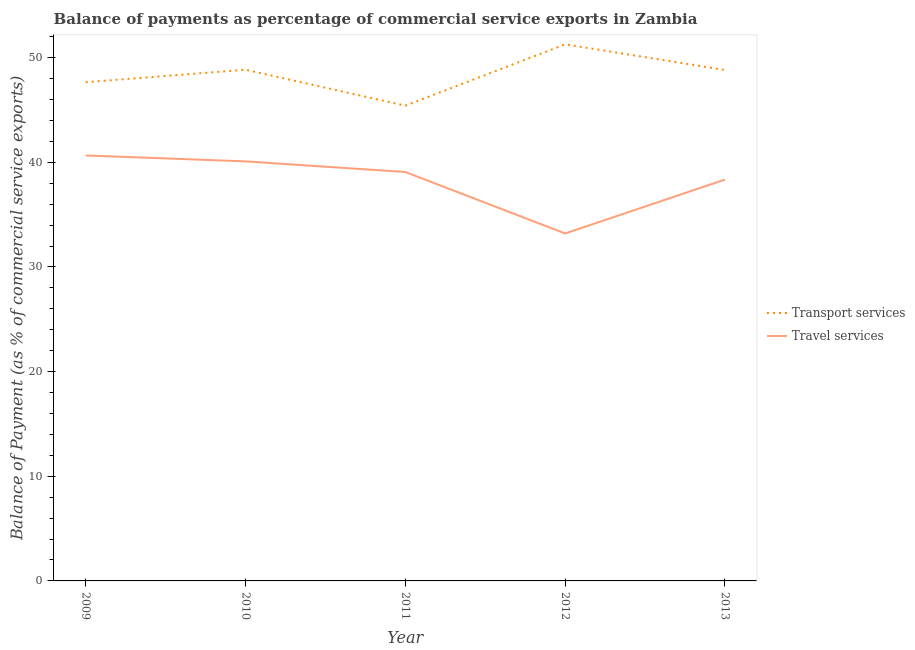How many different coloured lines are there?
Keep it short and to the point. 2. What is the balance of payments of transport services in 2012?
Keep it short and to the point. 51.27. Across all years, what is the maximum balance of payments of travel services?
Your answer should be very brief. 40.66. Across all years, what is the minimum balance of payments of transport services?
Your answer should be very brief. 45.41. In which year was the balance of payments of travel services maximum?
Make the answer very short. 2009. In which year was the balance of payments of travel services minimum?
Provide a succinct answer. 2012. What is the total balance of payments of travel services in the graph?
Keep it short and to the point. 191.37. What is the difference between the balance of payments of transport services in 2010 and that in 2013?
Provide a succinct answer. 0.03. What is the difference between the balance of payments of transport services in 2013 and the balance of payments of travel services in 2009?
Ensure brevity in your answer.  8.16. What is the average balance of payments of travel services per year?
Provide a short and direct response. 38.27. In the year 2009, what is the difference between the balance of payments of transport services and balance of payments of travel services?
Your answer should be very brief. 7. What is the ratio of the balance of payments of travel services in 2011 to that in 2013?
Provide a short and direct response. 1.02. Is the balance of payments of travel services in 2011 less than that in 2012?
Offer a very short reply. No. Is the difference between the balance of payments of transport services in 2010 and 2012 greater than the difference between the balance of payments of travel services in 2010 and 2012?
Ensure brevity in your answer.  No. What is the difference between the highest and the second highest balance of payments of transport services?
Ensure brevity in your answer.  2.43. What is the difference between the highest and the lowest balance of payments of travel services?
Keep it short and to the point. 7.45. Is the sum of the balance of payments of travel services in 2012 and 2013 greater than the maximum balance of payments of transport services across all years?
Offer a terse response. Yes. How many lines are there?
Give a very brief answer. 2. Are the values on the major ticks of Y-axis written in scientific E-notation?
Ensure brevity in your answer.  No. Does the graph contain any zero values?
Provide a short and direct response. No. Does the graph contain grids?
Provide a short and direct response. No. Where does the legend appear in the graph?
Provide a succinct answer. Center right. What is the title of the graph?
Give a very brief answer. Balance of payments as percentage of commercial service exports in Zambia. What is the label or title of the X-axis?
Provide a short and direct response. Year. What is the label or title of the Y-axis?
Your answer should be very brief. Balance of Payment (as % of commercial service exports). What is the Balance of Payment (as % of commercial service exports) of Transport services in 2009?
Your answer should be very brief. 47.66. What is the Balance of Payment (as % of commercial service exports) of Travel services in 2009?
Offer a very short reply. 40.66. What is the Balance of Payment (as % of commercial service exports) of Transport services in 2010?
Your response must be concise. 48.85. What is the Balance of Payment (as % of commercial service exports) in Travel services in 2010?
Offer a very short reply. 40.09. What is the Balance of Payment (as % of commercial service exports) in Transport services in 2011?
Your answer should be compact. 45.41. What is the Balance of Payment (as % of commercial service exports) in Travel services in 2011?
Keep it short and to the point. 39.07. What is the Balance of Payment (as % of commercial service exports) in Transport services in 2012?
Give a very brief answer. 51.27. What is the Balance of Payment (as % of commercial service exports) in Travel services in 2012?
Your response must be concise. 33.2. What is the Balance of Payment (as % of commercial service exports) of Transport services in 2013?
Provide a short and direct response. 48.82. What is the Balance of Payment (as % of commercial service exports) of Travel services in 2013?
Your answer should be compact. 38.35. Across all years, what is the maximum Balance of Payment (as % of commercial service exports) of Transport services?
Your response must be concise. 51.27. Across all years, what is the maximum Balance of Payment (as % of commercial service exports) of Travel services?
Offer a very short reply. 40.66. Across all years, what is the minimum Balance of Payment (as % of commercial service exports) in Transport services?
Offer a very short reply. 45.41. Across all years, what is the minimum Balance of Payment (as % of commercial service exports) in Travel services?
Your answer should be very brief. 33.2. What is the total Balance of Payment (as % of commercial service exports) in Transport services in the graph?
Provide a succinct answer. 242.01. What is the total Balance of Payment (as % of commercial service exports) of Travel services in the graph?
Give a very brief answer. 191.37. What is the difference between the Balance of Payment (as % of commercial service exports) of Transport services in 2009 and that in 2010?
Offer a very short reply. -1.19. What is the difference between the Balance of Payment (as % of commercial service exports) of Travel services in 2009 and that in 2010?
Give a very brief answer. 0.57. What is the difference between the Balance of Payment (as % of commercial service exports) of Transport services in 2009 and that in 2011?
Your response must be concise. 2.24. What is the difference between the Balance of Payment (as % of commercial service exports) of Travel services in 2009 and that in 2011?
Your response must be concise. 1.58. What is the difference between the Balance of Payment (as % of commercial service exports) in Transport services in 2009 and that in 2012?
Offer a very short reply. -3.62. What is the difference between the Balance of Payment (as % of commercial service exports) of Travel services in 2009 and that in 2012?
Provide a short and direct response. 7.45. What is the difference between the Balance of Payment (as % of commercial service exports) of Transport services in 2009 and that in 2013?
Your response must be concise. -1.16. What is the difference between the Balance of Payment (as % of commercial service exports) in Travel services in 2009 and that in 2013?
Ensure brevity in your answer.  2.31. What is the difference between the Balance of Payment (as % of commercial service exports) of Transport services in 2010 and that in 2011?
Provide a short and direct response. 3.43. What is the difference between the Balance of Payment (as % of commercial service exports) in Travel services in 2010 and that in 2011?
Provide a short and direct response. 1.02. What is the difference between the Balance of Payment (as % of commercial service exports) in Transport services in 2010 and that in 2012?
Your answer should be compact. -2.43. What is the difference between the Balance of Payment (as % of commercial service exports) of Travel services in 2010 and that in 2012?
Provide a succinct answer. 6.89. What is the difference between the Balance of Payment (as % of commercial service exports) in Transport services in 2010 and that in 2013?
Make the answer very short. 0.03. What is the difference between the Balance of Payment (as % of commercial service exports) in Travel services in 2010 and that in 2013?
Offer a terse response. 1.74. What is the difference between the Balance of Payment (as % of commercial service exports) of Transport services in 2011 and that in 2012?
Provide a short and direct response. -5.86. What is the difference between the Balance of Payment (as % of commercial service exports) of Travel services in 2011 and that in 2012?
Ensure brevity in your answer.  5.87. What is the difference between the Balance of Payment (as % of commercial service exports) of Transport services in 2011 and that in 2013?
Provide a succinct answer. -3.41. What is the difference between the Balance of Payment (as % of commercial service exports) of Travel services in 2011 and that in 2013?
Provide a succinct answer. 0.72. What is the difference between the Balance of Payment (as % of commercial service exports) of Transport services in 2012 and that in 2013?
Keep it short and to the point. 2.45. What is the difference between the Balance of Payment (as % of commercial service exports) in Travel services in 2012 and that in 2013?
Ensure brevity in your answer.  -5.15. What is the difference between the Balance of Payment (as % of commercial service exports) of Transport services in 2009 and the Balance of Payment (as % of commercial service exports) of Travel services in 2010?
Provide a succinct answer. 7.57. What is the difference between the Balance of Payment (as % of commercial service exports) of Transport services in 2009 and the Balance of Payment (as % of commercial service exports) of Travel services in 2011?
Provide a short and direct response. 8.58. What is the difference between the Balance of Payment (as % of commercial service exports) of Transport services in 2009 and the Balance of Payment (as % of commercial service exports) of Travel services in 2012?
Your response must be concise. 14.45. What is the difference between the Balance of Payment (as % of commercial service exports) of Transport services in 2009 and the Balance of Payment (as % of commercial service exports) of Travel services in 2013?
Provide a succinct answer. 9.3. What is the difference between the Balance of Payment (as % of commercial service exports) in Transport services in 2010 and the Balance of Payment (as % of commercial service exports) in Travel services in 2011?
Provide a short and direct response. 9.77. What is the difference between the Balance of Payment (as % of commercial service exports) of Transport services in 2010 and the Balance of Payment (as % of commercial service exports) of Travel services in 2012?
Keep it short and to the point. 15.64. What is the difference between the Balance of Payment (as % of commercial service exports) in Transport services in 2010 and the Balance of Payment (as % of commercial service exports) in Travel services in 2013?
Offer a very short reply. 10.5. What is the difference between the Balance of Payment (as % of commercial service exports) of Transport services in 2011 and the Balance of Payment (as % of commercial service exports) of Travel services in 2012?
Provide a short and direct response. 12.21. What is the difference between the Balance of Payment (as % of commercial service exports) in Transport services in 2011 and the Balance of Payment (as % of commercial service exports) in Travel services in 2013?
Provide a succinct answer. 7.06. What is the difference between the Balance of Payment (as % of commercial service exports) in Transport services in 2012 and the Balance of Payment (as % of commercial service exports) in Travel services in 2013?
Provide a short and direct response. 12.92. What is the average Balance of Payment (as % of commercial service exports) of Transport services per year?
Provide a short and direct response. 48.4. What is the average Balance of Payment (as % of commercial service exports) in Travel services per year?
Offer a terse response. 38.27. In the year 2009, what is the difference between the Balance of Payment (as % of commercial service exports) in Transport services and Balance of Payment (as % of commercial service exports) in Travel services?
Make the answer very short. 7. In the year 2010, what is the difference between the Balance of Payment (as % of commercial service exports) in Transport services and Balance of Payment (as % of commercial service exports) in Travel services?
Keep it short and to the point. 8.76. In the year 2011, what is the difference between the Balance of Payment (as % of commercial service exports) of Transport services and Balance of Payment (as % of commercial service exports) of Travel services?
Offer a very short reply. 6.34. In the year 2012, what is the difference between the Balance of Payment (as % of commercial service exports) in Transport services and Balance of Payment (as % of commercial service exports) in Travel services?
Make the answer very short. 18.07. In the year 2013, what is the difference between the Balance of Payment (as % of commercial service exports) in Transport services and Balance of Payment (as % of commercial service exports) in Travel services?
Offer a very short reply. 10.47. What is the ratio of the Balance of Payment (as % of commercial service exports) in Transport services in 2009 to that in 2010?
Provide a short and direct response. 0.98. What is the ratio of the Balance of Payment (as % of commercial service exports) of Travel services in 2009 to that in 2010?
Ensure brevity in your answer.  1.01. What is the ratio of the Balance of Payment (as % of commercial service exports) of Transport services in 2009 to that in 2011?
Your response must be concise. 1.05. What is the ratio of the Balance of Payment (as % of commercial service exports) of Travel services in 2009 to that in 2011?
Provide a succinct answer. 1.04. What is the ratio of the Balance of Payment (as % of commercial service exports) in Transport services in 2009 to that in 2012?
Provide a succinct answer. 0.93. What is the ratio of the Balance of Payment (as % of commercial service exports) in Travel services in 2009 to that in 2012?
Provide a short and direct response. 1.22. What is the ratio of the Balance of Payment (as % of commercial service exports) in Transport services in 2009 to that in 2013?
Give a very brief answer. 0.98. What is the ratio of the Balance of Payment (as % of commercial service exports) of Travel services in 2009 to that in 2013?
Your answer should be very brief. 1.06. What is the ratio of the Balance of Payment (as % of commercial service exports) in Transport services in 2010 to that in 2011?
Provide a succinct answer. 1.08. What is the ratio of the Balance of Payment (as % of commercial service exports) of Transport services in 2010 to that in 2012?
Your response must be concise. 0.95. What is the ratio of the Balance of Payment (as % of commercial service exports) in Travel services in 2010 to that in 2012?
Your answer should be compact. 1.21. What is the ratio of the Balance of Payment (as % of commercial service exports) in Travel services in 2010 to that in 2013?
Provide a short and direct response. 1.05. What is the ratio of the Balance of Payment (as % of commercial service exports) of Transport services in 2011 to that in 2012?
Your answer should be compact. 0.89. What is the ratio of the Balance of Payment (as % of commercial service exports) of Travel services in 2011 to that in 2012?
Provide a short and direct response. 1.18. What is the ratio of the Balance of Payment (as % of commercial service exports) in Transport services in 2011 to that in 2013?
Your answer should be very brief. 0.93. What is the ratio of the Balance of Payment (as % of commercial service exports) of Travel services in 2011 to that in 2013?
Provide a short and direct response. 1.02. What is the ratio of the Balance of Payment (as % of commercial service exports) in Transport services in 2012 to that in 2013?
Offer a very short reply. 1.05. What is the ratio of the Balance of Payment (as % of commercial service exports) in Travel services in 2012 to that in 2013?
Provide a succinct answer. 0.87. What is the difference between the highest and the second highest Balance of Payment (as % of commercial service exports) in Transport services?
Your answer should be compact. 2.43. What is the difference between the highest and the second highest Balance of Payment (as % of commercial service exports) in Travel services?
Provide a succinct answer. 0.57. What is the difference between the highest and the lowest Balance of Payment (as % of commercial service exports) in Transport services?
Your response must be concise. 5.86. What is the difference between the highest and the lowest Balance of Payment (as % of commercial service exports) in Travel services?
Make the answer very short. 7.45. 